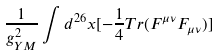<formula> <loc_0><loc_0><loc_500><loc_500>\frac { 1 } { g _ { Y M } ^ { 2 } } \int d ^ { 2 6 } x [ - \frac { 1 } { 4 } T r ( F ^ { \mu \nu } F _ { \mu \nu } ) ]</formula> 